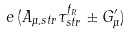Convert formula to latex. <formula><loc_0><loc_0><loc_500><loc_500>e \, ( A _ { \mu , s t r } \tau _ { s t r } ^ { f _ { R } } \pm G ^ { \prime } _ { \mu } )</formula> 